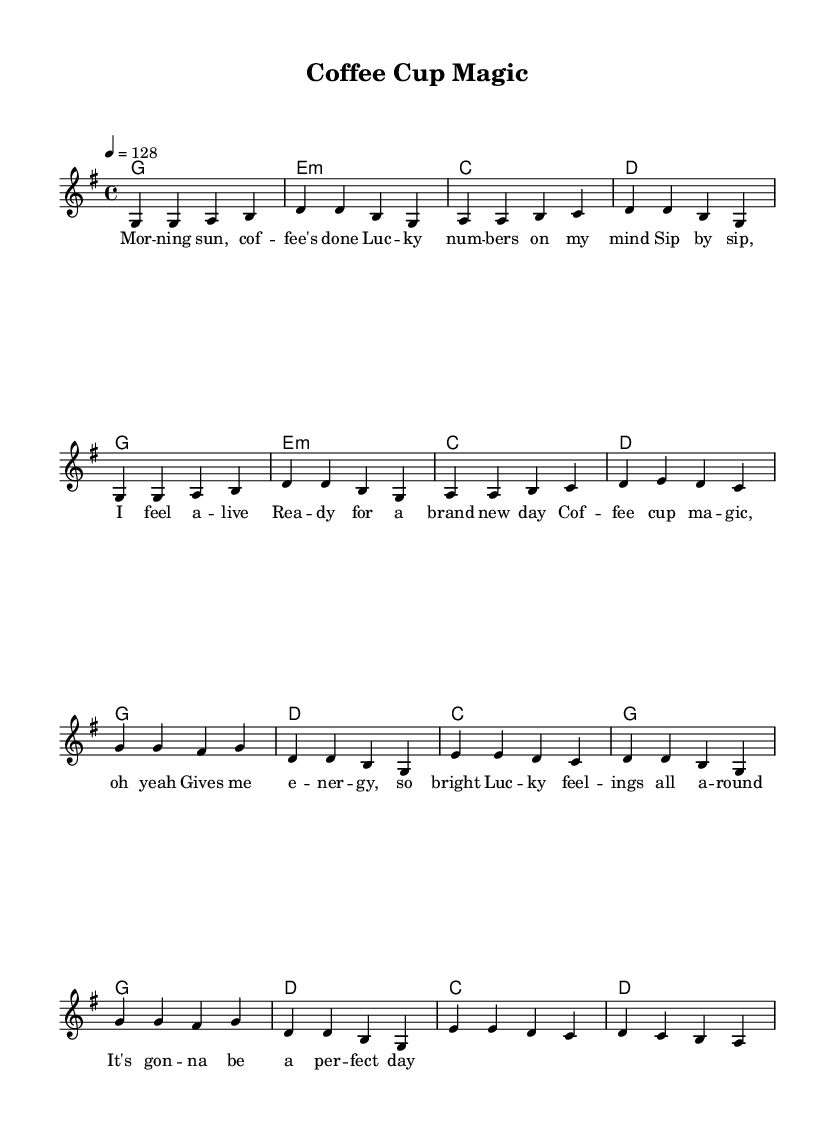What is the key signature of this music? The key signature is G major, which has one sharp (F#). This is indicated by the key signature symbol at the beginning of the staff.
Answer: G major What is the time signature of this music? The time signature is 4/4, which means there are four beats in each measure and the quarter note receives one beat. This is typically indicated at the start of the piece.
Answer: 4/4 What is the tempo marking of this music? The tempo marking indicates a speed of 128 beats per minute. This is noted above the staff in the form of a tempo directive (4 = 128).
Answer: 128 How many measures are in the verse section? The verse section contains four measures, which can be counted from the start to the end of the verse part of the score. Each bar separates the measures.
Answer: Four How does the chorus differ from the verse musically? The chorus follows a different melodic pattern and harmonic structure than the verse. The melodies in the chorus use slightly different notes, and the chord progression also differs between the sections. This can be observed by comparing the notes and chords outlined in the respective parts.
Answer: Different melody and harmony What theme does the lyrics of this piece convey? The lyrics convey a theme of positivity and energy associated with coffee in the morning, emphasizing feelings of luck and readiness for the day. This thematic interpretation comes from reading through the text provided alongside the musical notes.
Answer: Positivity and energy 